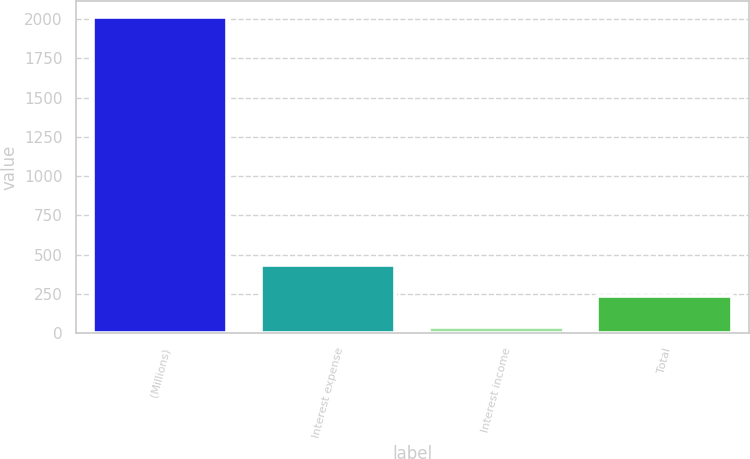<chart> <loc_0><loc_0><loc_500><loc_500><bar_chart><fcel>(Millions)<fcel>Interest expense<fcel>Interest income<fcel>Total<nl><fcel>2013<fcel>435.4<fcel>41<fcel>238.2<nl></chart> 